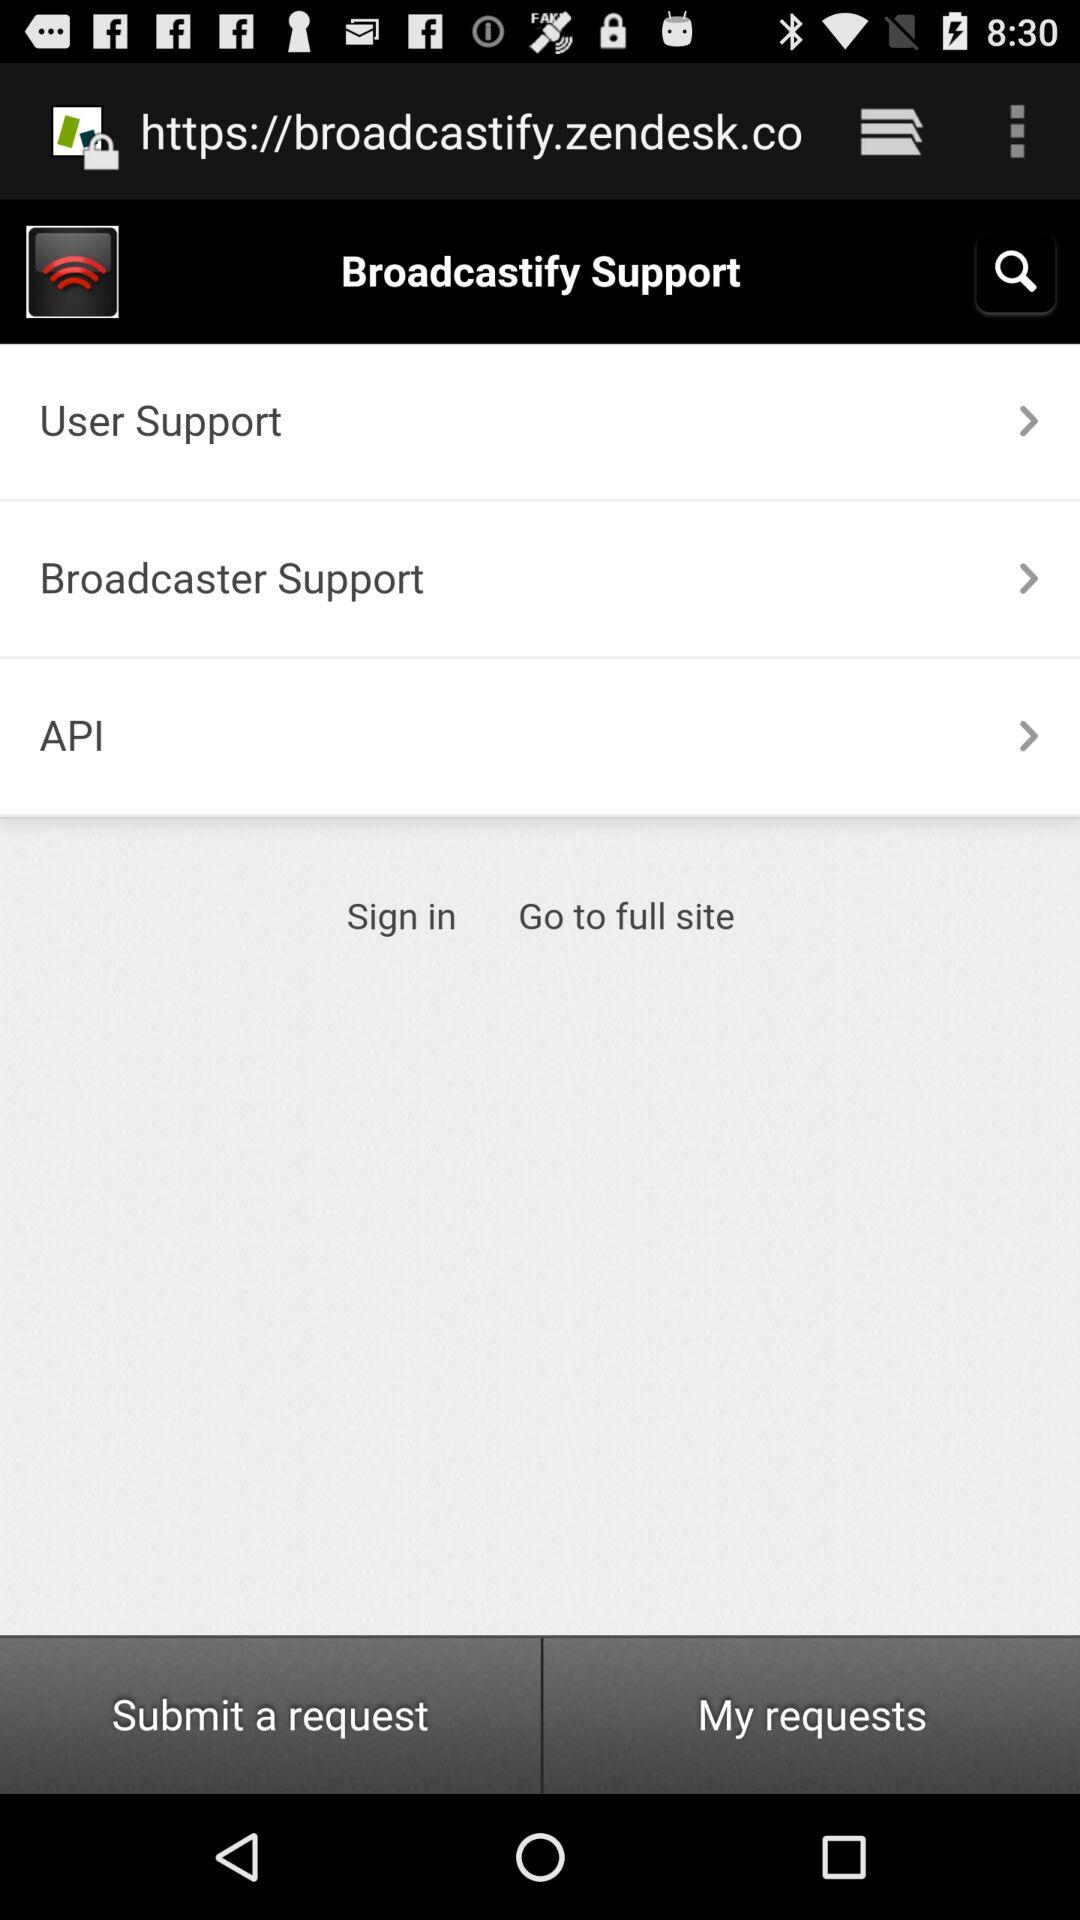What is the application name? The application name is "Broadcastify". 